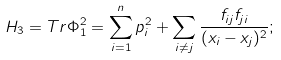Convert formula to latex. <formula><loc_0><loc_0><loc_500><loc_500>H _ { 3 } = T r \Phi _ { 1 } ^ { 2 } = \sum _ { i = 1 } ^ { n } p _ { i } ^ { 2 } + \sum _ { i \neq j } \frac { f _ { i j } f _ { j i } } { ( x _ { i } - x _ { j } ) ^ { 2 } } ;</formula> 